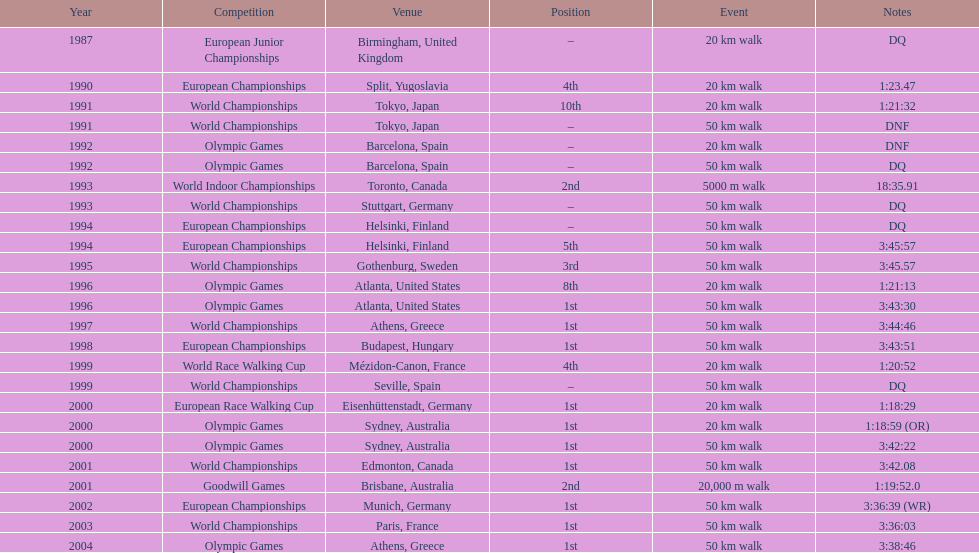How much time was required to complete a 50 km walk in the 2004 olympics? 3:38:46. 